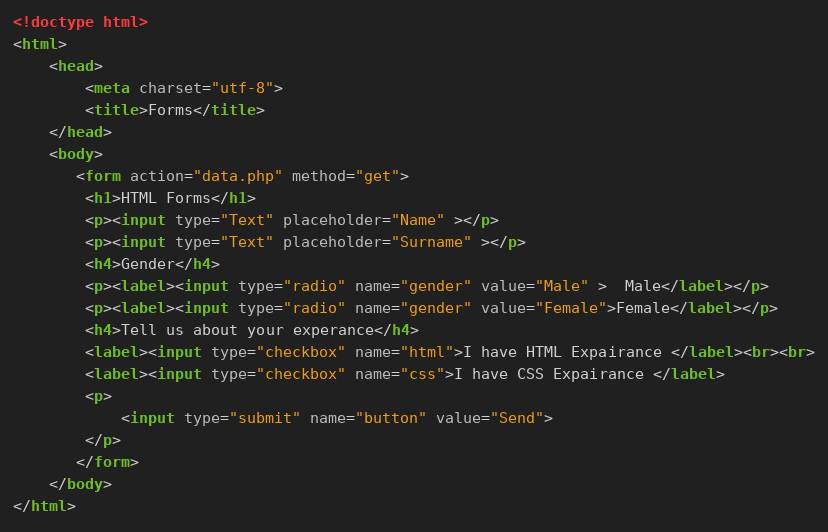Convert code to text. <code><loc_0><loc_0><loc_500><loc_500><_HTML_><!doctype html>
<html>
    <head>
        <meta charset="utf-8">
        <title>Forms</title>
    </head>
    <body>
       <form action="data.php" method="get">
       	<h1>HTML Forms</h1>
       	<p><input type="Text" placeholder="Name" ></p>
       	<p><input type="Text" placeholder="Surname" ></p>
       	<h4>Gender</h4>
       	<p><label><input type="radio" name="gender" value="Male" >  Male</label></p>
       	<p><label><input type="radio" name="gender" value="Female">Female</label></p>
       	<h4>Tell us about your experance</h4>
       	<label><input type="checkbox" name="html">I have HTML Expairance </label><br><br>
       	<label><input type="checkbox" name="css">I have CSS Expairance </label>
       	<p>
       		<input type="submit" name="button" value="Send">
       	</p>
       </form> 
    </body>
</html></code> 